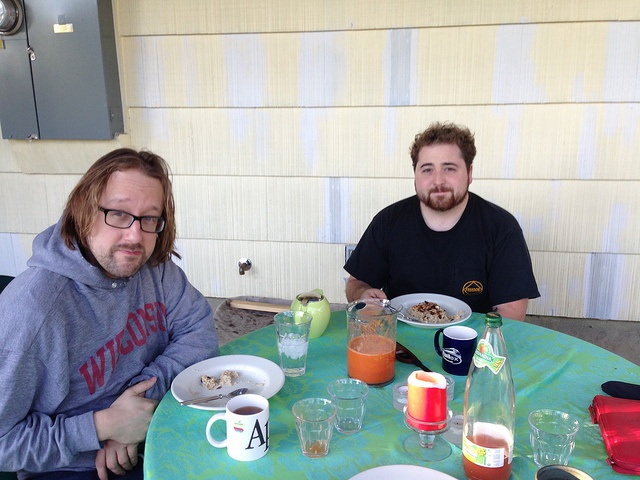Describe the objects in this image and their specific colors. I can see dining table in darkgray, teal, and lavender tones, people in darkgray, gray, and black tones, people in darkgray, black, lightpink, and gray tones, bottle in darkgray, teal, white, and salmon tones, and cup in darkgray, white, turquoise, gray, and lightblue tones in this image. 